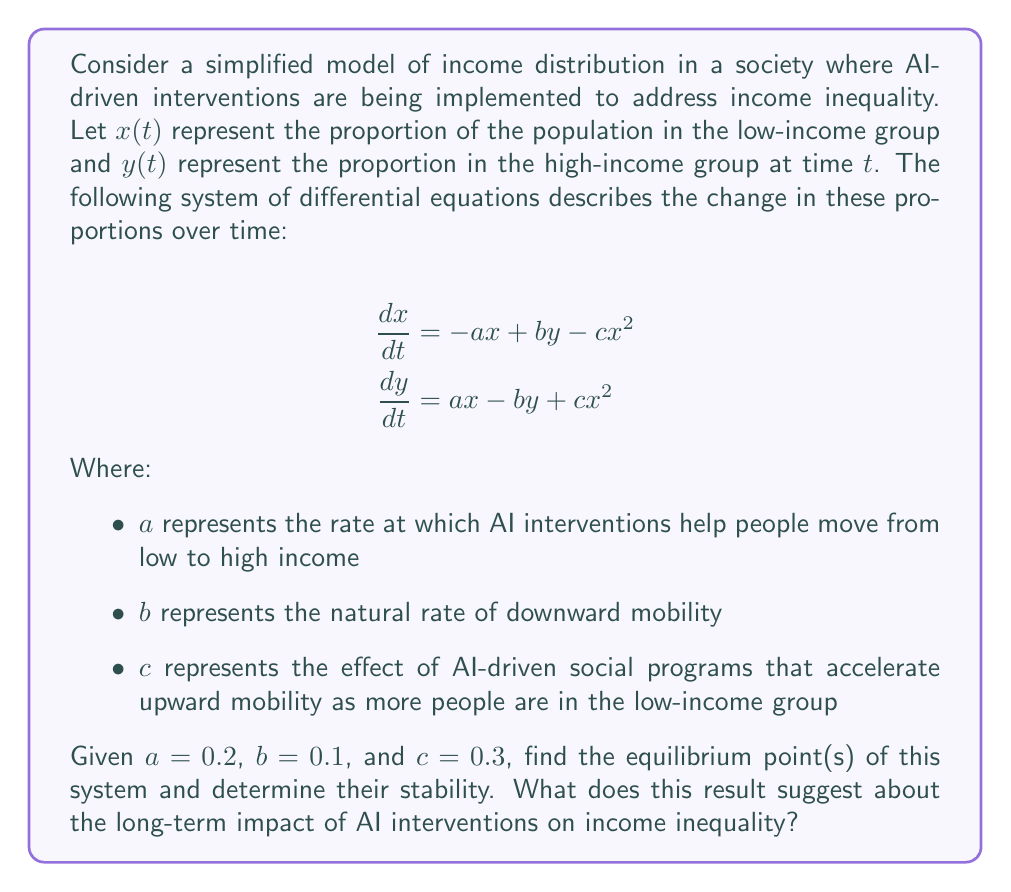Can you answer this question? To solve this problem, we'll follow these steps:

1. Find the equilibrium points by setting the derivatives to zero.
2. Solve the resulting system of equations.
3. Analyze the stability of the equilibrium points.

Step 1: Set the derivatives to zero

$$\begin{align}
0 &= -ax + by - cx^2 \\
0 &= ax - by + cx^2
\end{align}$$

Step 2: Solve the system of equations

Note that $x + y = 1$ since they represent proportions of the total population. We can substitute $y = 1 - x$ into the first equation:

$$\begin{align}
0 &= -ax + b(1-x) - cx^2 \\
0 &= -ax + b - bx - cx^2 \\
cx^2 + (a-b)x - b &= 0
\end{align}$$

This is a quadratic equation. Let's substitute the given values: $a = 0.2$, $b = 0.1$, and $c = 0.3$

$$0.3x^2 + 0.1x - 0.1 = 0$$

Using the quadratic formula, we get:

$$x = \frac{-0.1 \pm \sqrt{0.1^2 + 4(0.3)(0.1)}}{2(0.3)} = \frac{-0.1 \pm \sqrt{0.13}}{0.6}$$

This gives us two solutions:
$x_1 \approx 0.4349$ and $x_2 \approx -0.7682$

Since $x$ represents a proportion, we discard the negative solution. Therefore, the equilibrium point is:

$$(x^*, y^*) = (0.4349, 0.5651)$$

Step 3: Analyze stability

To determine stability, we need to find the Jacobian matrix and evaluate it at the equilibrium point:

$$J = \begin{bmatrix}
-a - 2cx & b \\
a + 2cx & -b
\end{bmatrix}$$

Evaluating at the equilibrium point:

$$J_{(x^*, y^*)} = \begin{bmatrix}
-0.2 - 2(0.3)(0.4349) & 0.1 \\
0.2 + 2(0.3)(0.4349) & -0.1
\end{bmatrix} = \begin{bmatrix}
-0.4609 & 0.1 \\
0.4609 & -0.1
\end{bmatrix}$$

The eigenvalues of this matrix are $\lambda_1 \approx -0.5609$ and $\lambda_2 = 0$. Since one eigenvalue is negative and the other is zero, this equilibrium point is neutrally stable.

This result suggests that in the long term, the AI interventions will lead to a stable income distribution with approximately 43.49% in the low-income group and 56.51% in the high-income group. The neutral stability implies that small perturbations won't cause the system to rapidly diverge from this equilibrium, but it also won't quickly return to it.
Answer: The system has one relevant equilibrium point at $(x^*, y^*) = (0.4349, 0.5651)$, which is neutrally stable. This suggests that AI interventions will lead to a long-term income distribution with 43.49% in the low-income group and 56.51% in the high-income group, maintaining a stable but not necessarily decreasing level of income inequality. 